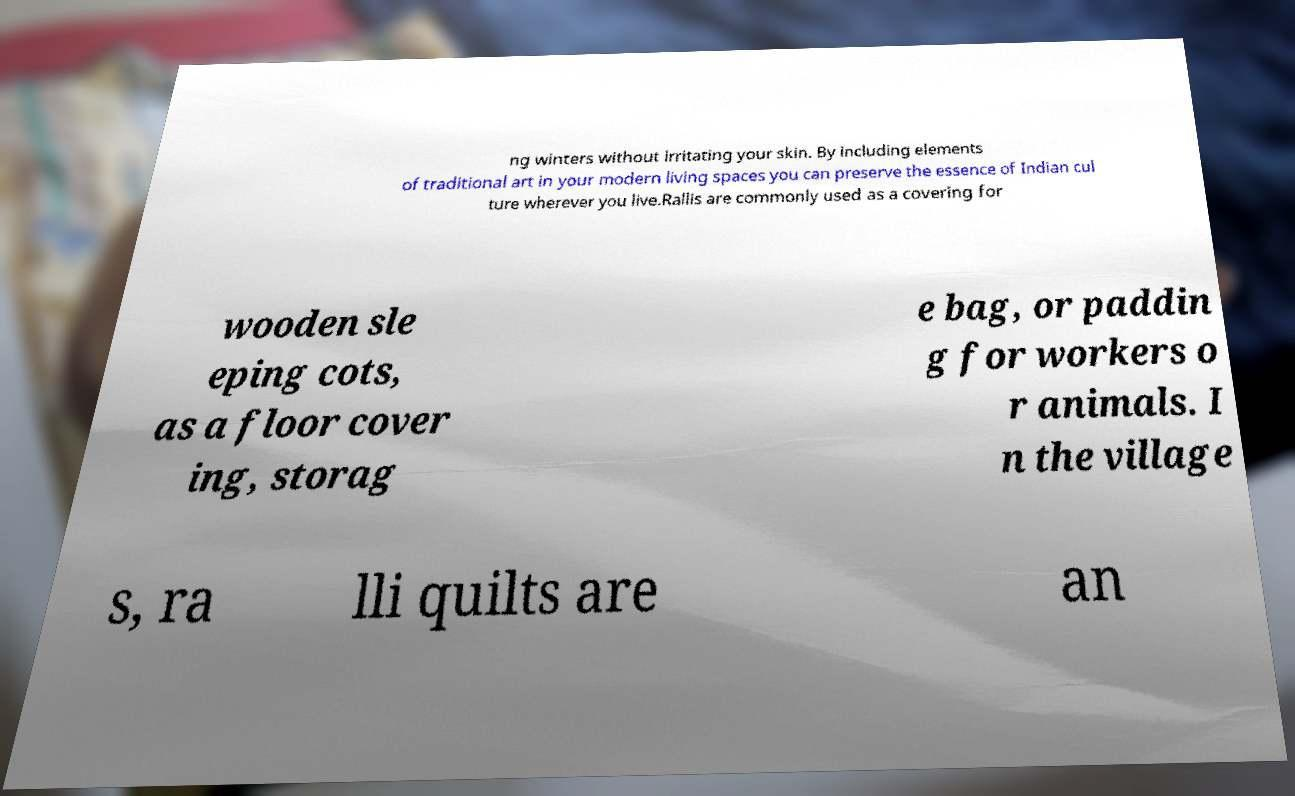Can you accurately transcribe the text from the provided image for me? ng winters without irritating your skin. By including elements of traditional art in your modern living spaces you can preserve the essence of Indian cul ture wherever you live.Rallis are commonly used as a covering for wooden sle eping cots, as a floor cover ing, storag e bag, or paddin g for workers o r animals. I n the village s, ra lli quilts are an 